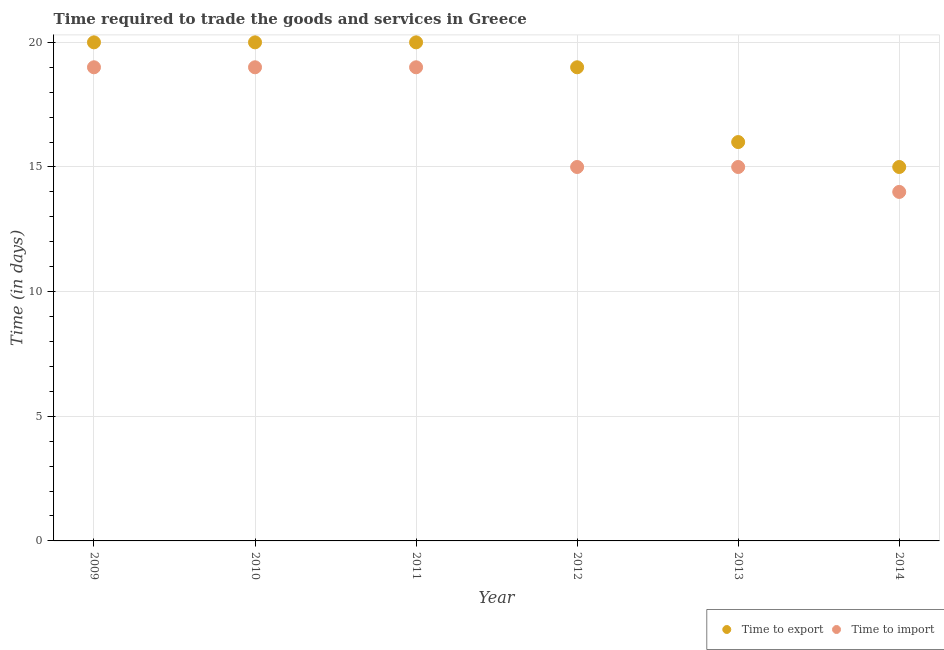How many different coloured dotlines are there?
Offer a terse response. 2. Is the number of dotlines equal to the number of legend labels?
Make the answer very short. Yes. What is the time to export in 2011?
Give a very brief answer. 20. Across all years, what is the maximum time to export?
Your answer should be very brief. 20. Across all years, what is the minimum time to export?
Make the answer very short. 15. What is the total time to import in the graph?
Offer a terse response. 101. What is the difference between the time to export in 2009 and that in 2010?
Make the answer very short. 0. What is the average time to import per year?
Offer a very short reply. 16.83. In the year 2013, what is the difference between the time to import and time to export?
Keep it short and to the point. -1. What is the ratio of the time to import in 2009 to that in 2010?
Your answer should be very brief. 1. Is the time to import in 2009 less than that in 2012?
Offer a very short reply. No. Is the difference between the time to export in 2013 and 2014 greater than the difference between the time to import in 2013 and 2014?
Provide a short and direct response. No. What is the difference between the highest and the second highest time to import?
Make the answer very short. 0. What is the difference between the highest and the lowest time to export?
Ensure brevity in your answer.  5. In how many years, is the time to import greater than the average time to import taken over all years?
Ensure brevity in your answer.  3. Is the sum of the time to export in 2011 and 2013 greater than the maximum time to import across all years?
Ensure brevity in your answer.  Yes. Is the time to import strictly less than the time to export over the years?
Make the answer very short. Yes. How many dotlines are there?
Provide a short and direct response. 2. How many years are there in the graph?
Keep it short and to the point. 6. Does the graph contain grids?
Ensure brevity in your answer.  Yes. Where does the legend appear in the graph?
Keep it short and to the point. Bottom right. How many legend labels are there?
Your answer should be very brief. 2. How are the legend labels stacked?
Give a very brief answer. Horizontal. What is the title of the graph?
Ensure brevity in your answer.  Time required to trade the goods and services in Greece. Does "Current US$" appear as one of the legend labels in the graph?
Provide a succinct answer. No. What is the label or title of the X-axis?
Give a very brief answer. Year. What is the label or title of the Y-axis?
Your answer should be very brief. Time (in days). What is the Time (in days) of Time to export in 2009?
Your response must be concise. 20. What is the Time (in days) in Time to import in 2009?
Your answer should be very brief. 19. What is the Time (in days) of Time to export in 2010?
Your answer should be very brief. 20. What is the Time (in days) in Time to import in 2012?
Your answer should be compact. 15. What is the Time (in days) in Time to import in 2013?
Provide a short and direct response. 15. What is the Time (in days) of Time to export in 2014?
Offer a very short reply. 15. What is the Time (in days) of Time to import in 2014?
Make the answer very short. 14. Across all years, what is the maximum Time (in days) of Time to export?
Keep it short and to the point. 20. Across all years, what is the maximum Time (in days) in Time to import?
Your answer should be very brief. 19. Across all years, what is the minimum Time (in days) of Time to export?
Offer a very short reply. 15. Across all years, what is the minimum Time (in days) in Time to import?
Give a very brief answer. 14. What is the total Time (in days) of Time to export in the graph?
Your response must be concise. 110. What is the total Time (in days) in Time to import in the graph?
Give a very brief answer. 101. What is the difference between the Time (in days) of Time to export in 2009 and that in 2011?
Offer a terse response. 0. What is the difference between the Time (in days) in Time to import in 2009 and that in 2012?
Provide a short and direct response. 4. What is the difference between the Time (in days) of Time to export in 2009 and that in 2014?
Your response must be concise. 5. What is the difference between the Time (in days) of Time to import in 2010 and that in 2013?
Your response must be concise. 4. What is the difference between the Time (in days) in Time to export in 2010 and that in 2014?
Keep it short and to the point. 5. What is the difference between the Time (in days) of Time to import in 2010 and that in 2014?
Your response must be concise. 5. What is the difference between the Time (in days) in Time to export in 2011 and that in 2013?
Offer a very short reply. 4. What is the difference between the Time (in days) of Time to export in 2011 and that in 2014?
Provide a succinct answer. 5. What is the difference between the Time (in days) in Time to import in 2011 and that in 2014?
Offer a very short reply. 5. What is the difference between the Time (in days) of Time to export in 2012 and that in 2013?
Your answer should be compact. 3. What is the difference between the Time (in days) of Time to import in 2012 and that in 2013?
Offer a very short reply. 0. What is the difference between the Time (in days) in Time to export in 2012 and that in 2014?
Your answer should be very brief. 4. What is the difference between the Time (in days) of Time to import in 2012 and that in 2014?
Your answer should be compact. 1. What is the difference between the Time (in days) of Time to export in 2013 and that in 2014?
Make the answer very short. 1. What is the difference between the Time (in days) of Time to import in 2013 and that in 2014?
Give a very brief answer. 1. What is the difference between the Time (in days) of Time to export in 2009 and the Time (in days) of Time to import in 2011?
Make the answer very short. 1. What is the difference between the Time (in days) in Time to export in 2009 and the Time (in days) in Time to import in 2013?
Make the answer very short. 5. What is the difference between the Time (in days) in Time to export in 2009 and the Time (in days) in Time to import in 2014?
Your answer should be compact. 6. What is the difference between the Time (in days) in Time to export in 2010 and the Time (in days) in Time to import in 2011?
Your answer should be compact. 1. What is the difference between the Time (in days) in Time to export in 2010 and the Time (in days) in Time to import in 2012?
Offer a terse response. 5. What is the difference between the Time (in days) of Time to export in 2010 and the Time (in days) of Time to import in 2014?
Your answer should be compact. 6. What is the difference between the Time (in days) of Time to export in 2011 and the Time (in days) of Time to import in 2012?
Keep it short and to the point. 5. What is the difference between the Time (in days) in Time to export in 2011 and the Time (in days) in Time to import in 2013?
Offer a terse response. 5. What is the difference between the Time (in days) in Time to export in 2012 and the Time (in days) in Time to import in 2013?
Your answer should be very brief. 4. What is the difference between the Time (in days) in Time to export in 2013 and the Time (in days) in Time to import in 2014?
Keep it short and to the point. 2. What is the average Time (in days) in Time to export per year?
Give a very brief answer. 18.33. What is the average Time (in days) in Time to import per year?
Offer a very short reply. 16.83. In the year 2009, what is the difference between the Time (in days) in Time to export and Time (in days) in Time to import?
Offer a very short reply. 1. In the year 2010, what is the difference between the Time (in days) of Time to export and Time (in days) of Time to import?
Your answer should be very brief. 1. In the year 2013, what is the difference between the Time (in days) of Time to export and Time (in days) of Time to import?
Your answer should be compact. 1. What is the ratio of the Time (in days) of Time to export in 2009 to that in 2011?
Make the answer very short. 1. What is the ratio of the Time (in days) of Time to import in 2009 to that in 2011?
Ensure brevity in your answer.  1. What is the ratio of the Time (in days) of Time to export in 2009 to that in 2012?
Keep it short and to the point. 1.05. What is the ratio of the Time (in days) of Time to import in 2009 to that in 2012?
Make the answer very short. 1.27. What is the ratio of the Time (in days) of Time to import in 2009 to that in 2013?
Ensure brevity in your answer.  1.27. What is the ratio of the Time (in days) in Time to import in 2009 to that in 2014?
Provide a short and direct response. 1.36. What is the ratio of the Time (in days) of Time to import in 2010 to that in 2011?
Ensure brevity in your answer.  1. What is the ratio of the Time (in days) of Time to export in 2010 to that in 2012?
Provide a succinct answer. 1.05. What is the ratio of the Time (in days) of Time to import in 2010 to that in 2012?
Make the answer very short. 1.27. What is the ratio of the Time (in days) of Time to export in 2010 to that in 2013?
Your answer should be compact. 1.25. What is the ratio of the Time (in days) of Time to import in 2010 to that in 2013?
Your answer should be very brief. 1.27. What is the ratio of the Time (in days) in Time to import in 2010 to that in 2014?
Your response must be concise. 1.36. What is the ratio of the Time (in days) of Time to export in 2011 to that in 2012?
Give a very brief answer. 1.05. What is the ratio of the Time (in days) of Time to import in 2011 to that in 2012?
Your answer should be compact. 1.27. What is the ratio of the Time (in days) of Time to import in 2011 to that in 2013?
Offer a terse response. 1.27. What is the ratio of the Time (in days) in Time to export in 2011 to that in 2014?
Give a very brief answer. 1.33. What is the ratio of the Time (in days) of Time to import in 2011 to that in 2014?
Your answer should be compact. 1.36. What is the ratio of the Time (in days) of Time to export in 2012 to that in 2013?
Your answer should be compact. 1.19. What is the ratio of the Time (in days) in Time to import in 2012 to that in 2013?
Make the answer very short. 1. What is the ratio of the Time (in days) in Time to export in 2012 to that in 2014?
Make the answer very short. 1.27. What is the ratio of the Time (in days) of Time to import in 2012 to that in 2014?
Ensure brevity in your answer.  1.07. What is the ratio of the Time (in days) in Time to export in 2013 to that in 2014?
Make the answer very short. 1.07. What is the ratio of the Time (in days) of Time to import in 2013 to that in 2014?
Offer a terse response. 1.07. What is the difference between the highest and the second highest Time (in days) of Time to export?
Your answer should be very brief. 0. What is the difference between the highest and the lowest Time (in days) of Time to export?
Make the answer very short. 5. 